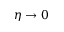<formula> <loc_0><loc_0><loc_500><loc_500>\eta \to 0</formula> 